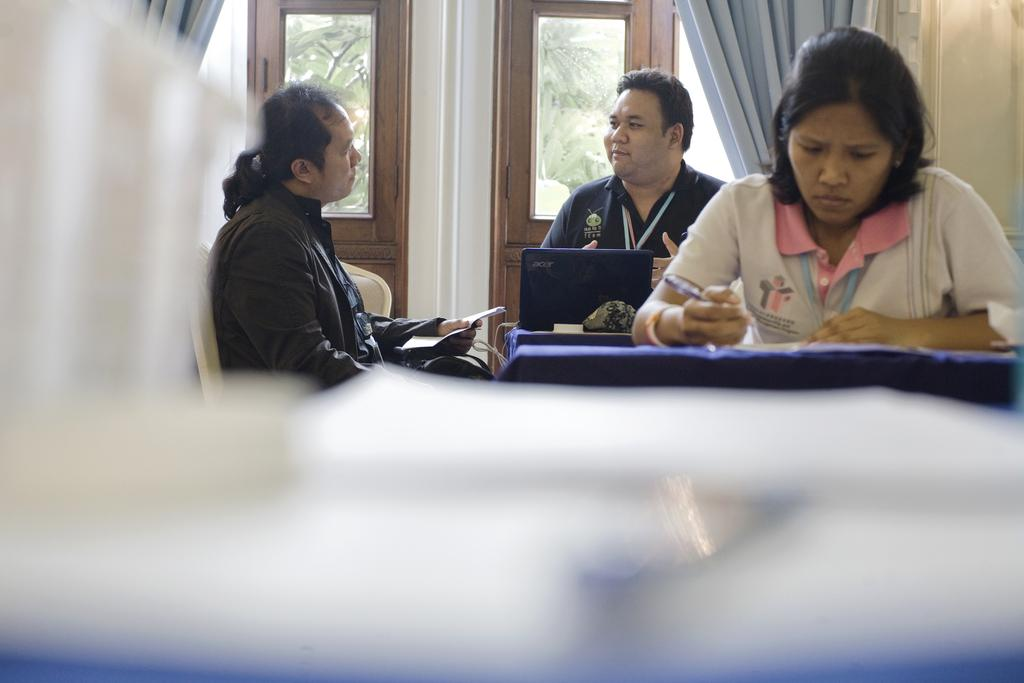What are the people in the image doing? The people in the image are sitting. What objects are present in the image that the people might be using? There are tables in the image, and a laptop is present on the tables. What else can be seen on the tables besides the laptop? There are other things placed on the tables. What can be seen in the background of the image? There is a door and a curtain in the background of the image. Can you see any teeth on the snail in the image? There is no snail present in the image, and therefore no teeth can be observed. 